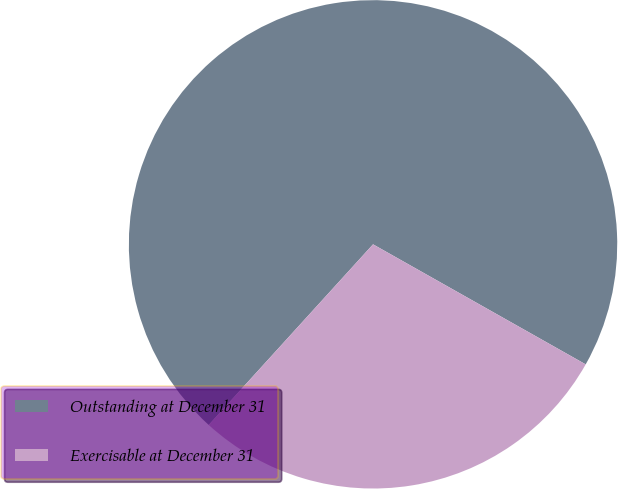<chart> <loc_0><loc_0><loc_500><loc_500><pie_chart><fcel>Outstanding at December 31<fcel>Exercisable at December 31<nl><fcel>71.43%<fcel>28.57%<nl></chart> 